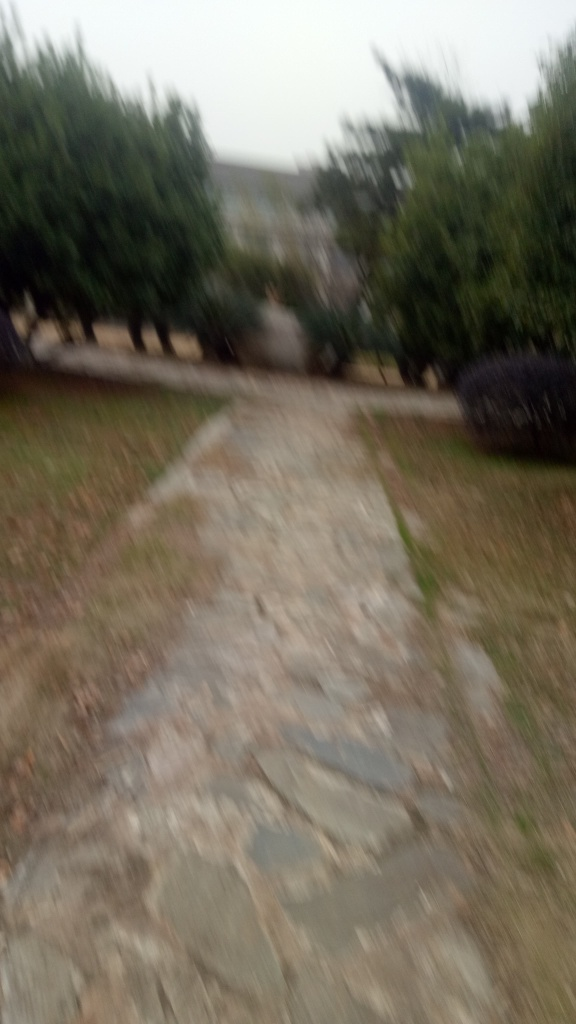If this image was intentional, what artistic value might it have? If the blur was intentional, it could convey a sense of motion, passage of time, or an abstract interpretation of space. Artistic value is subjective and the viewer might be encouraged to focus on the emotional impact or the mood evoked by the blurred scenery, rather than on concrete details. 